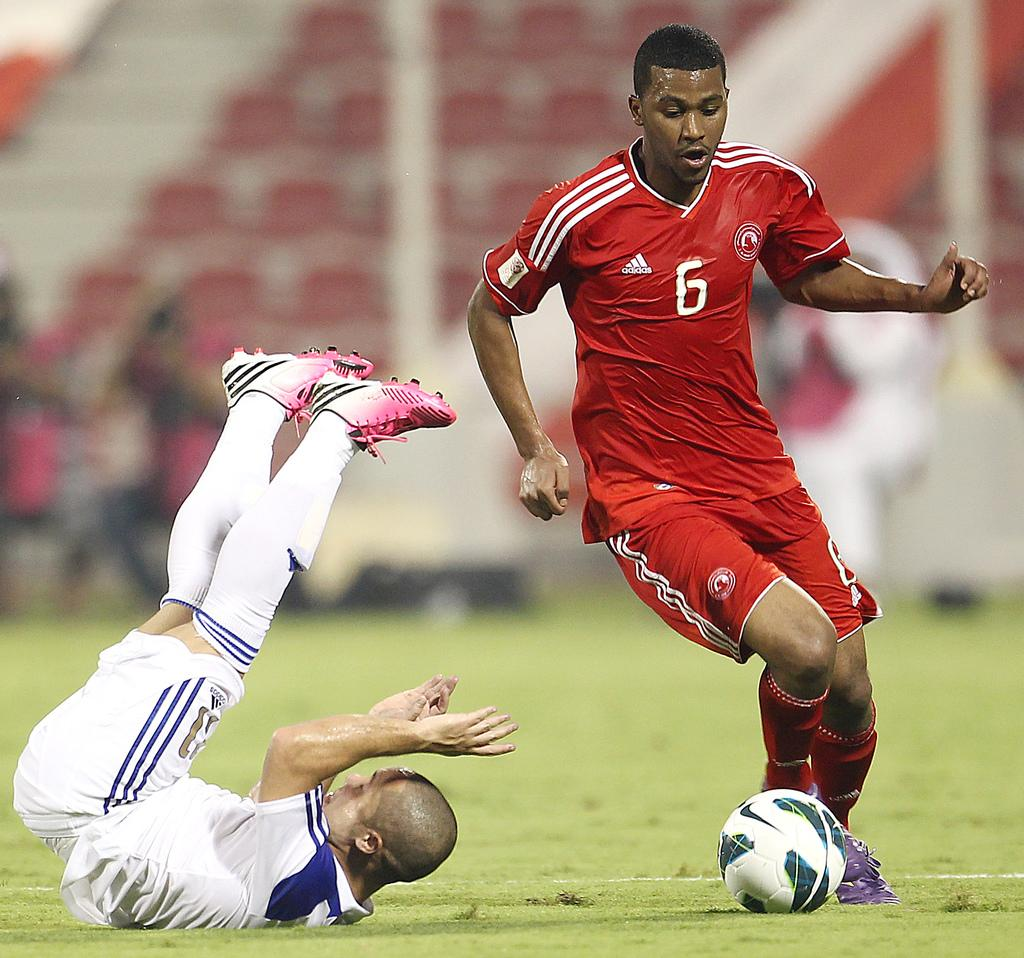What are the two persons in the image doing? The two persons in the image are playing. Where are they playing? They are playing on the ground. What can be seen in the background of the image? There are chairs, people, and poles in the background of the image. What type of seed is being planted by the persons in the image? There is no seed or planting activity depicted in the image; the persons are playing on the ground. Can you see a lamp in the image? There is no lamp present in the image. 